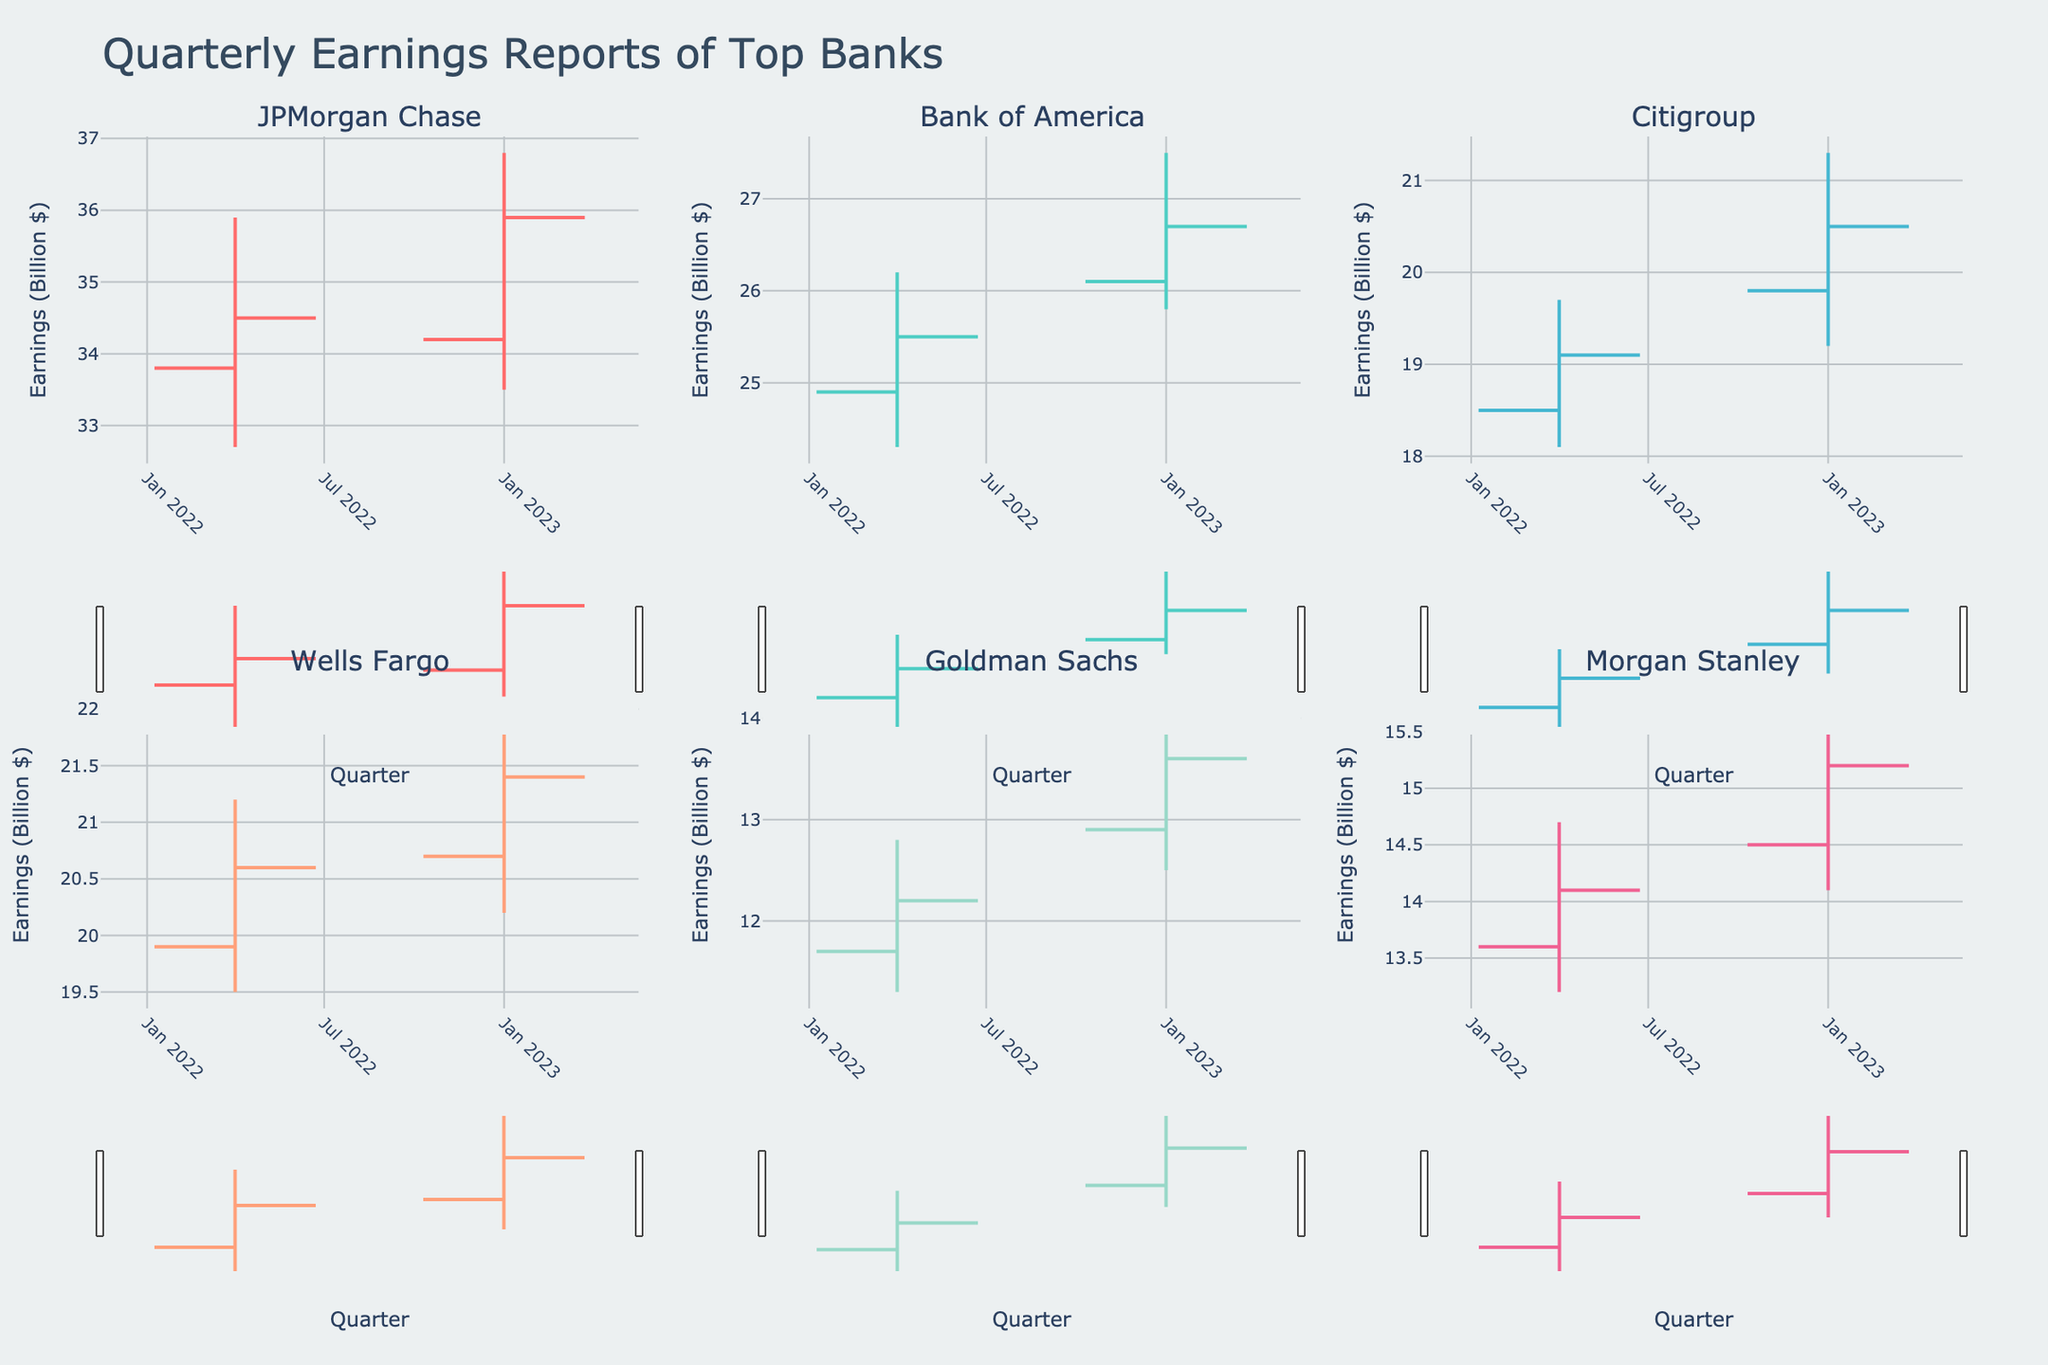What is the title of the figure? The title can be found at the top of the figure. It provides a summary of what the data represents.
Answer: Quarterly Earnings Reports of Top Banks Which bank had the highest high value in Q1 2023? Look for the highest high value (peak) in the subplots for Q1 2023. Match the value to the corresponding bank.
Answer: JPMorgan Chase Which bank had a higher closing value in Q4 2022, Citigroup or Wells Fargo? Check the closing values for Citigroup and Wells Fargo in Q4 2022 and compare them.
Answer: Wells Fargo What was the opening value for Morgan Stanley in Q4 2022? Identify the subplot for Morgan Stanley and locate its opening value bar in Q4 2022.
Answer: 13.6 How did the closing value of Bank of America change from Q4 2022 to Q1 2023? Track the closing values for both quarters and calculate the difference.
Answer: Increase by 1.2 (from 25.5 to 26.7) Which bank had the lowest low value in Q4 2022? Check the low values for each bank in Q4 2022 and determine which one is the smallest.
Answer: Goldman Sachs Between Q4 2022 and Q1 2023, which quarter had more volatility (difference between High and Low) for Wells Fargo? Calculate the difference between the high and low values for Wells Fargo in each quarter and compare them.
Answer: Q1 2023 What is the overall trend for JPMorgan Chase from Q4 2022 to Q1 2023? Examine the opening and closing values of JPMorgan Chase in both quarters to identify the trend.
Answer: Upward Which bank showed the highest profit based on the closing values in Q1 2023? Compare the closing values of all banks in Q1 2023 to find the highest value.
Answer: JPMorgan Chase Did the closing value for Goldman Sachs increase or decrease from Q4 2022 to Q1 2023? Compare the closing values for Goldman Sachs in both quarters to see the change.
Answer: Increase 